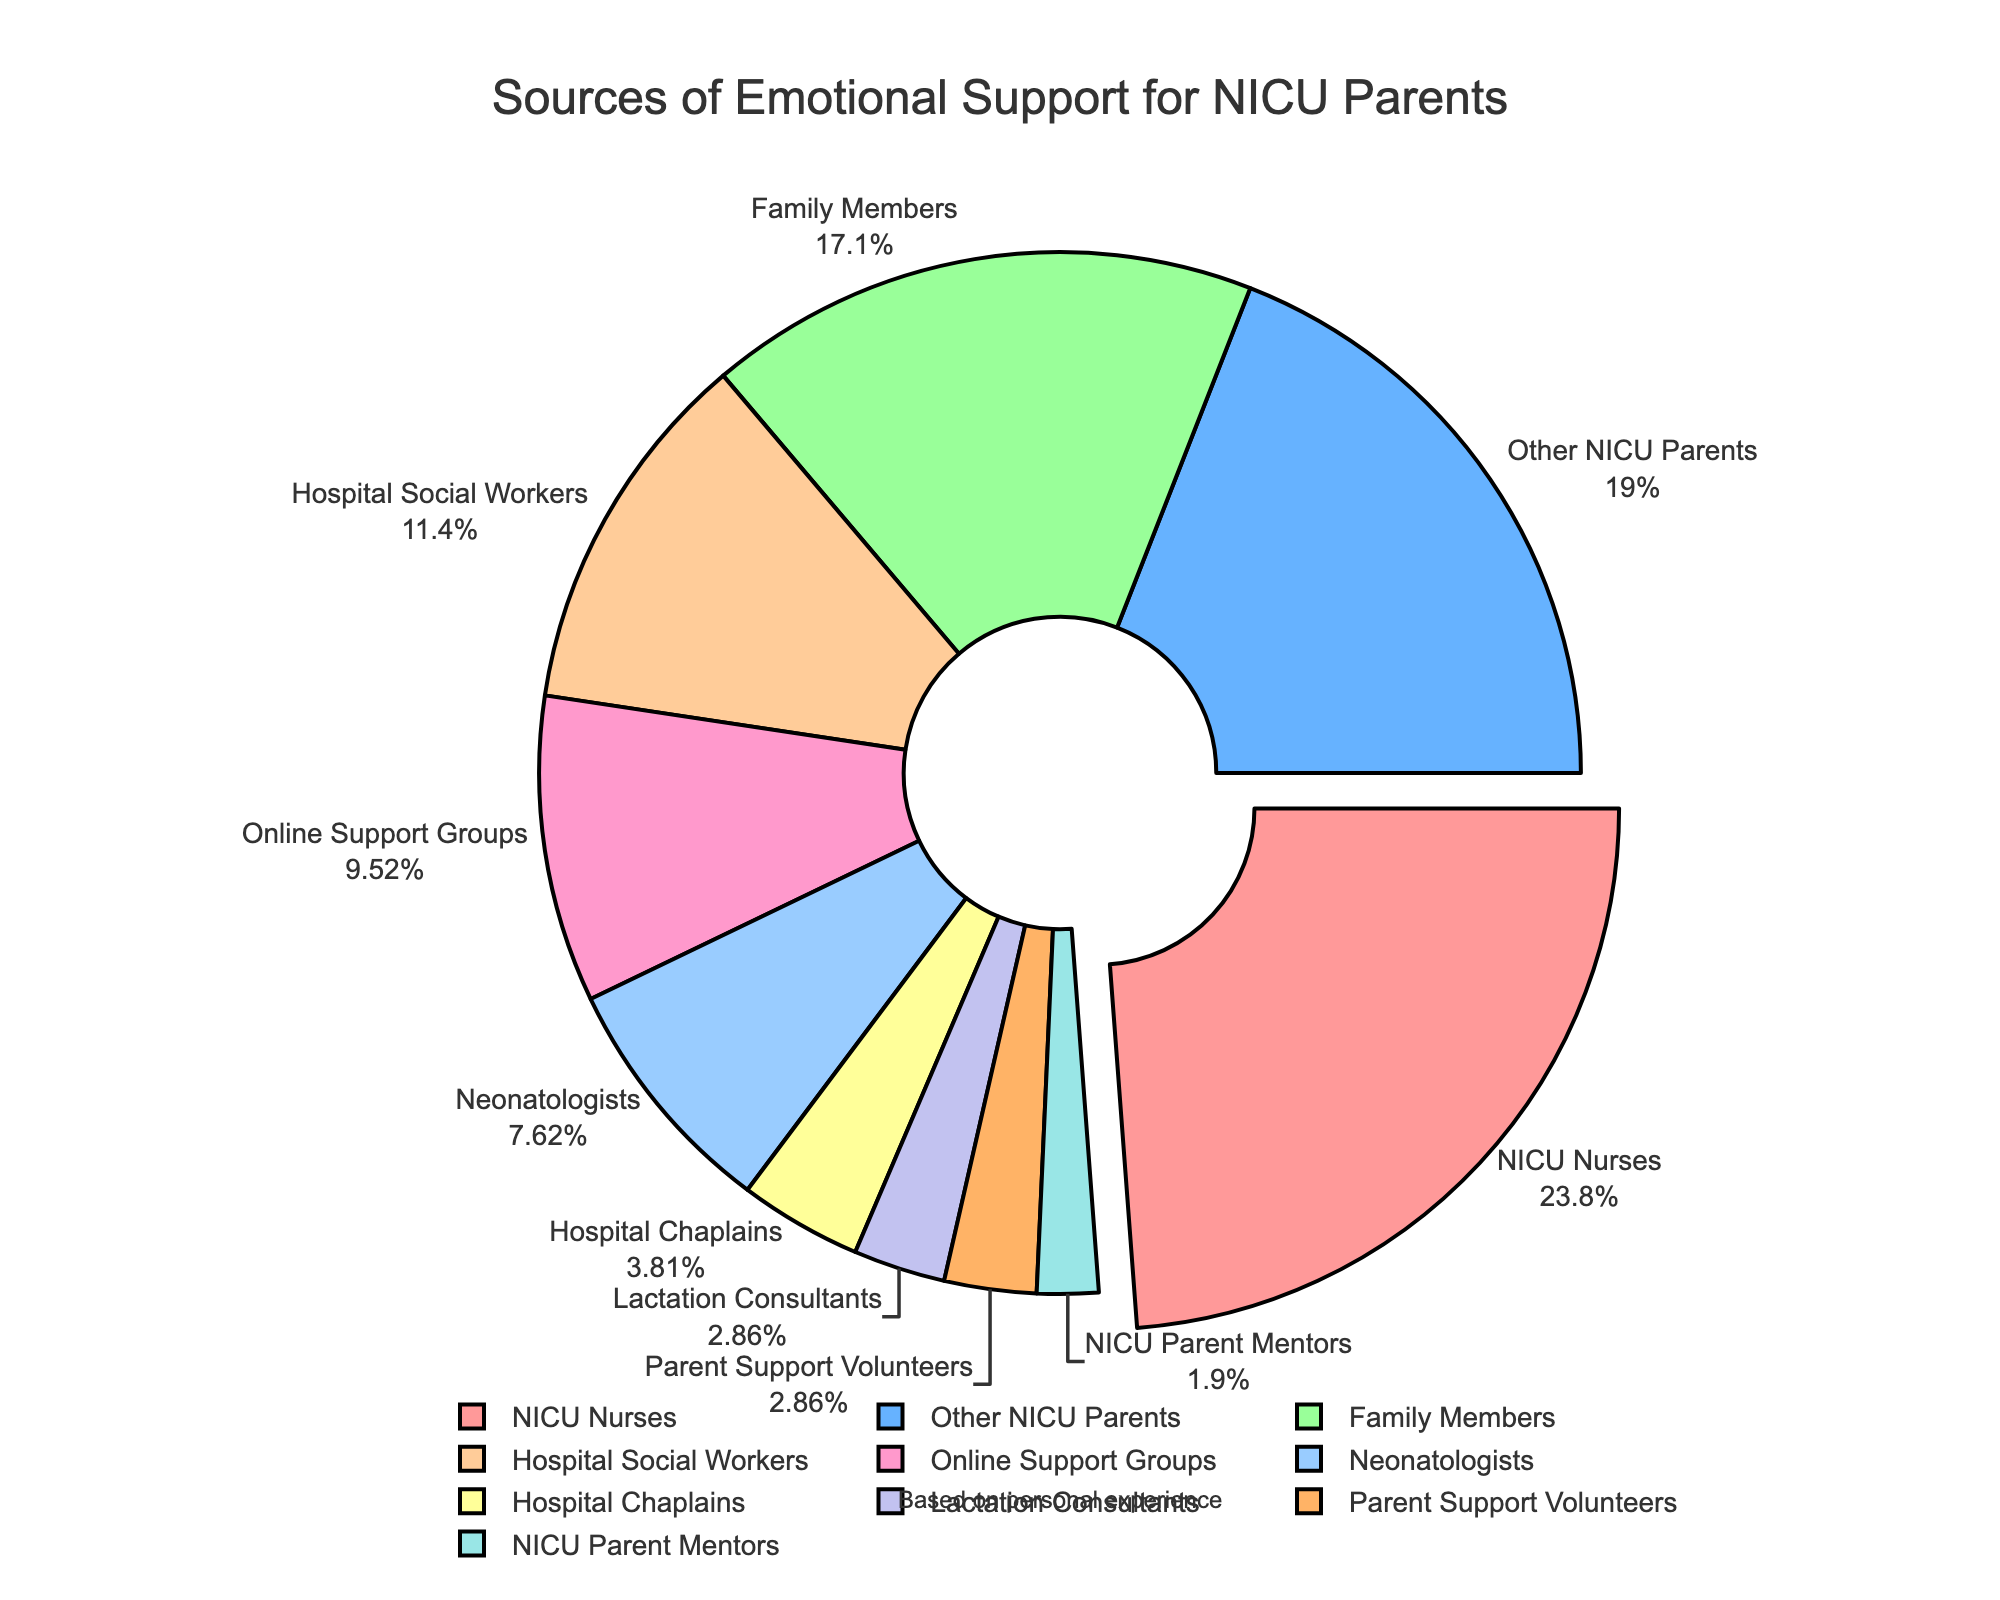What's the largest source of emotional support for NICU parents according to the pie chart? The largest slice of the pie chart represents NICU Nurses, which covers 25% of the chart.
Answer: NICU Nurses Which two sources contribute equally to the emotional support of NICU parents? Two sources, Lactation Consultants and Parent Support Volunteers, each contribute 3% to the emotional support, as shown by equal-sized slices.
Answer: Lactation Consultants and Parent Support Volunteers What is the combined percentage of support provided by Hospital Chaplains, Lactation Consultants, Parent Support Volunteers, and NICU Parent Mentors? Adding the percentages of Hospital Chaplains (4%), Lactation Consultants (3%), Parent Support Volunteers (3%), and NICU Parent Mentors (2%) gives a total of 4 + 3 + 3 + 2 = 12%.
Answer: 12% Which source of support is more significant: Family Members or Other NICU Parents? The pie chart shows Family Members have 18%, and Other NICU Parents have 20%, so Other NICU Parents is more significant.
Answer: Other NICU Parents How much more support do NICU Nurses provide compared to Neonatologists? NICU Nurses provide 25%, while Neonatologists provide 8%. The difference is 25 - 8 = 17%.
Answer: 17% What is the total percentage contribution of the top three sources of support? The top three sources are NICU Nurses (25%), Other NICU Parents (20%), and Family Members (18%). Adding these, 25 + 20 + 18 = 63%.
Answer: 63% Which source of support has the smallest percentage and what is it? NICU Parent Mentors have the smallest percentage, which is 2%.
Answer: NICU Parent Mentors What percentage of support is provided by sources that each contribute less than 10%? Sources contributing less than 10% are Neonatologists (8%), Hospital Chaplains (4%), Lactation Consultants (3%), Parent Support Volunteers (3%), and NICU Parent Mentors (2%). Adding them, 8 + 4 + 3 + 3 + 2 = 20%.
Answer: 20% How much more percentage does Hospital Social Workers contribute than Online Support Groups? Hospital Social Workers contribute 12%, while Online Support Groups contribute 10%, so the difference is 12 - 10 = 2%.
Answer: 2% 